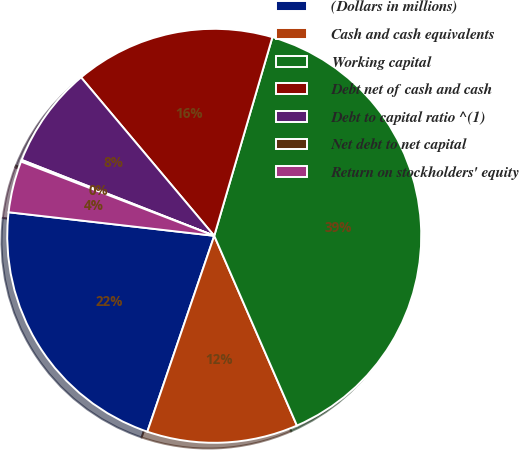Convert chart. <chart><loc_0><loc_0><loc_500><loc_500><pie_chart><fcel>(Dollars in millions)<fcel>Cash and cash equivalents<fcel>Working capital<fcel>Debt net of cash and cash<fcel>Debt to capital ratio ^(1)<fcel>Net debt to net capital<fcel>Return on stockholders' equity<nl><fcel>21.58%<fcel>11.78%<fcel>38.93%<fcel>15.66%<fcel>7.9%<fcel>0.14%<fcel>4.02%<nl></chart> 